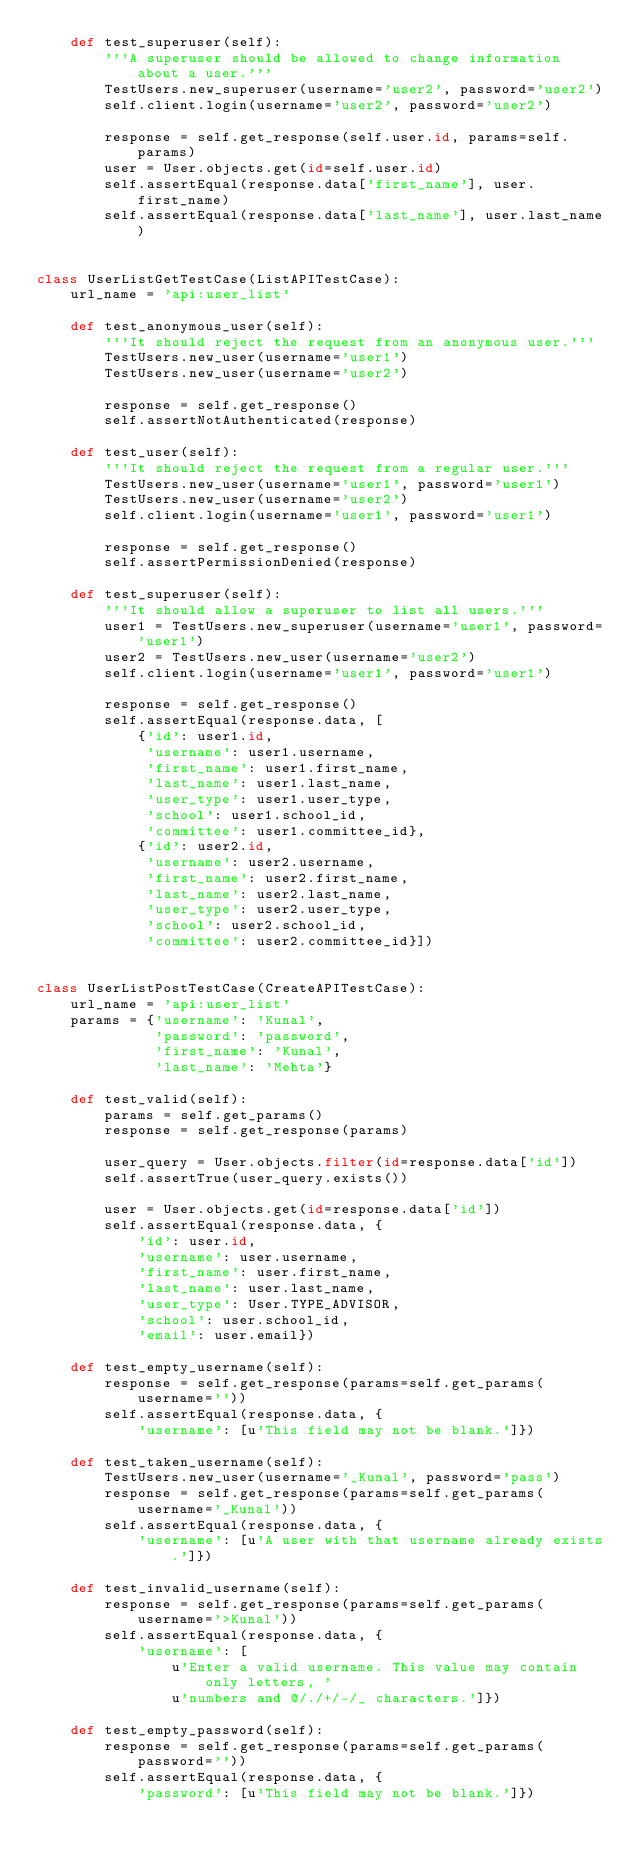<code> <loc_0><loc_0><loc_500><loc_500><_Python_>    def test_superuser(self):
        '''A superuser should be allowed to change information about a user.'''
        TestUsers.new_superuser(username='user2', password='user2')
        self.client.login(username='user2', password='user2')

        response = self.get_response(self.user.id, params=self.params)
        user = User.objects.get(id=self.user.id)
        self.assertEqual(response.data['first_name'], user.first_name)
        self.assertEqual(response.data['last_name'], user.last_name)


class UserListGetTestCase(ListAPITestCase):
    url_name = 'api:user_list'

    def test_anonymous_user(self):
        '''It should reject the request from an anonymous user.'''
        TestUsers.new_user(username='user1')
        TestUsers.new_user(username='user2')

        response = self.get_response()
        self.assertNotAuthenticated(response)

    def test_user(self):
        '''It should reject the request from a regular user.'''
        TestUsers.new_user(username='user1', password='user1')
        TestUsers.new_user(username='user2')
        self.client.login(username='user1', password='user1')

        response = self.get_response()
        self.assertPermissionDenied(response)

    def test_superuser(self):
        '''It should allow a superuser to list all users.'''
        user1 = TestUsers.new_superuser(username='user1', password='user1')
        user2 = TestUsers.new_user(username='user2')
        self.client.login(username='user1', password='user1')

        response = self.get_response()
        self.assertEqual(response.data, [
            {'id': user1.id,
             'username': user1.username,
             'first_name': user1.first_name,
             'last_name': user1.last_name,
             'user_type': user1.user_type,
             'school': user1.school_id,
             'committee': user1.committee_id},
            {'id': user2.id,
             'username': user2.username,
             'first_name': user2.first_name,
             'last_name': user2.last_name,
             'user_type': user2.user_type,
             'school': user2.school_id,
             'committee': user2.committee_id}])


class UserListPostTestCase(CreateAPITestCase):
    url_name = 'api:user_list'
    params = {'username': 'Kunal',
              'password': 'password',
              'first_name': 'Kunal',
              'last_name': 'Mehta'}

    def test_valid(self):
        params = self.get_params()
        response = self.get_response(params)

        user_query = User.objects.filter(id=response.data['id'])
        self.assertTrue(user_query.exists())

        user = User.objects.get(id=response.data['id'])
        self.assertEqual(response.data, {
            'id': user.id,
            'username': user.username,
            'first_name': user.first_name,
            'last_name': user.last_name,
            'user_type': User.TYPE_ADVISOR,
            'school': user.school_id,
            'email': user.email})

    def test_empty_username(self):
        response = self.get_response(params=self.get_params(username=''))
        self.assertEqual(response.data, {
            'username': [u'This field may not be blank.']})

    def test_taken_username(self):
        TestUsers.new_user(username='_Kunal', password='pass')
        response = self.get_response(params=self.get_params(username='_Kunal'))
        self.assertEqual(response.data, {
            'username': [u'A user with that username already exists.']})

    def test_invalid_username(self):
        response = self.get_response(params=self.get_params(username='>Kunal'))
        self.assertEqual(response.data, {
            'username': [
                u'Enter a valid username. This value may contain only letters, '
                u'numbers and @/./+/-/_ characters.']})

    def test_empty_password(self):
        response = self.get_response(params=self.get_params(password=''))
        self.assertEqual(response.data, {
            'password': [u'This field may not be blank.']})
</code> 